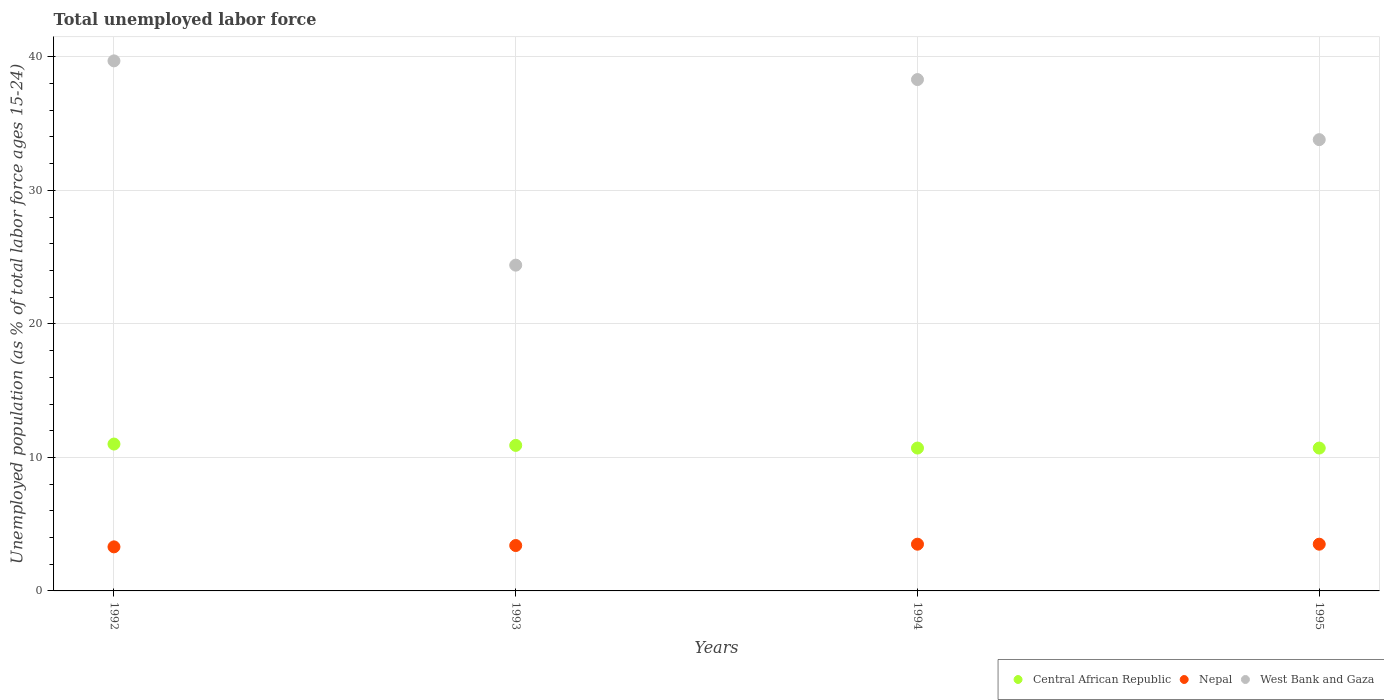Is the number of dotlines equal to the number of legend labels?
Make the answer very short. Yes. What is the percentage of unemployed population in in Central African Republic in 1993?
Make the answer very short. 10.9. Across all years, what is the maximum percentage of unemployed population in in West Bank and Gaza?
Keep it short and to the point. 39.7. Across all years, what is the minimum percentage of unemployed population in in Central African Republic?
Your answer should be compact. 10.7. In which year was the percentage of unemployed population in in West Bank and Gaza maximum?
Your answer should be compact. 1992. What is the total percentage of unemployed population in in West Bank and Gaza in the graph?
Your answer should be compact. 136.2. What is the difference between the percentage of unemployed population in in Nepal in 1992 and that in 1993?
Give a very brief answer. -0.1. What is the difference between the percentage of unemployed population in in Nepal in 1992 and the percentage of unemployed population in in Central African Republic in 1995?
Keep it short and to the point. -7.4. What is the average percentage of unemployed population in in West Bank and Gaza per year?
Provide a short and direct response. 34.05. In the year 1993, what is the difference between the percentage of unemployed population in in Nepal and percentage of unemployed population in in Central African Republic?
Give a very brief answer. -7.5. In how many years, is the percentage of unemployed population in in Nepal greater than 6 %?
Make the answer very short. 0. Is the difference between the percentage of unemployed population in in Nepal in 1992 and 1993 greater than the difference between the percentage of unemployed population in in Central African Republic in 1992 and 1993?
Ensure brevity in your answer.  No. What is the difference between the highest and the second highest percentage of unemployed population in in West Bank and Gaza?
Provide a short and direct response. 1.4. What is the difference between the highest and the lowest percentage of unemployed population in in West Bank and Gaza?
Provide a short and direct response. 15.3. Is the sum of the percentage of unemployed population in in West Bank and Gaza in 1992 and 1994 greater than the maximum percentage of unemployed population in in Central African Republic across all years?
Ensure brevity in your answer.  Yes. Does the percentage of unemployed population in in Nepal monotonically increase over the years?
Your answer should be very brief. No. How many dotlines are there?
Ensure brevity in your answer.  3. What is the difference between two consecutive major ticks on the Y-axis?
Make the answer very short. 10. Does the graph contain any zero values?
Provide a succinct answer. No. What is the title of the graph?
Give a very brief answer. Total unemployed labor force. What is the label or title of the X-axis?
Ensure brevity in your answer.  Years. What is the label or title of the Y-axis?
Provide a succinct answer. Unemployed population (as % of total labor force ages 15-24). What is the Unemployed population (as % of total labor force ages 15-24) of Central African Republic in 1992?
Your answer should be very brief. 11. What is the Unemployed population (as % of total labor force ages 15-24) of Nepal in 1992?
Offer a very short reply. 3.3. What is the Unemployed population (as % of total labor force ages 15-24) in West Bank and Gaza in 1992?
Your response must be concise. 39.7. What is the Unemployed population (as % of total labor force ages 15-24) in Central African Republic in 1993?
Provide a short and direct response. 10.9. What is the Unemployed population (as % of total labor force ages 15-24) of Nepal in 1993?
Provide a short and direct response. 3.4. What is the Unemployed population (as % of total labor force ages 15-24) of West Bank and Gaza in 1993?
Your answer should be very brief. 24.4. What is the Unemployed population (as % of total labor force ages 15-24) in Central African Republic in 1994?
Your response must be concise. 10.7. What is the Unemployed population (as % of total labor force ages 15-24) of Nepal in 1994?
Ensure brevity in your answer.  3.5. What is the Unemployed population (as % of total labor force ages 15-24) of West Bank and Gaza in 1994?
Make the answer very short. 38.3. What is the Unemployed population (as % of total labor force ages 15-24) in Central African Republic in 1995?
Give a very brief answer. 10.7. What is the Unemployed population (as % of total labor force ages 15-24) of Nepal in 1995?
Your response must be concise. 3.5. What is the Unemployed population (as % of total labor force ages 15-24) of West Bank and Gaza in 1995?
Keep it short and to the point. 33.8. Across all years, what is the maximum Unemployed population (as % of total labor force ages 15-24) of Nepal?
Provide a succinct answer. 3.5. Across all years, what is the maximum Unemployed population (as % of total labor force ages 15-24) of West Bank and Gaza?
Ensure brevity in your answer.  39.7. Across all years, what is the minimum Unemployed population (as % of total labor force ages 15-24) of Central African Republic?
Offer a terse response. 10.7. Across all years, what is the minimum Unemployed population (as % of total labor force ages 15-24) in Nepal?
Make the answer very short. 3.3. Across all years, what is the minimum Unemployed population (as % of total labor force ages 15-24) of West Bank and Gaza?
Your response must be concise. 24.4. What is the total Unemployed population (as % of total labor force ages 15-24) in Central African Republic in the graph?
Your answer should be very brief. 43.3. What is the total Unemployed population (as % of total labor force ages 15-24) of West Bank and Gaza in the graph?
Your response must be concise. 136.2. What is the difference between the Unemployed population (as % of total labor force ages 15-24) in Nepal in 1993 and that in 1994?
Give a very brief answer. -0.1. What is the difference between the Unemployed population (as % of total labor force ages 15-24) of West Bank and Gaza in 1993 and that in 1994?
Ensure brevity in your answer.  -13.9. What is the difference between the Unemployed population (as % of total labor force ages 15-24) of Central African Republic in 1994 and that in 1995?
Your answer should be compact. 0. What is the difference between the Unemployed population (as % of total labor force ages 15-24) in Central African Republic in 1992 and the Unemployed population (as % of total labor force ages 15-24) in Nepal in 1993?
Provide a succinct answer. 7.6. What is the difference between the Unemployed population (as % of total labor force ages 15-24) in Nepal in 1992 and the Unemployed population (as % of total labor force ages 15-24) in West Bank and Gaza in 1993?
Your response must be concise. -21.1. What is the difference between the Unemployed population (as % of total labor force ages 15-24) in Central African Republic in 1992 and the Unemployed population (as % of total labor force ages 15-24) in Nepal in 1994?
Your response must be concise. 7.5. What is the difference between the Unemployed population (as % of total labor force ages 15-24) in Central African Republic in 1992 and the Unemployed population (as % of total labor force ages 15-24) in West Bank and Gaza in 1994?
Provide a succinct answer. -27.3. What is the difference between the Unemployed population (as % of total labor force ages 15-24) in Nepal in 1992 and the Unemployed population (as % of total labor force ages 15-24) in West Bank and Gaza in 1994?
Provide a succinct answer. -35. What is the difference between the Unemployed population (as % of total labor force ages 15-24) of Central African Republic in 1992 and the Unemployed population (as % of total labor force ages 15-24) of Nepal in 1995?
Your response must be concise. 7.5. What is the difference between the Unemployed population (as % of total labor force ages 15-24) of Central African Republic in 1992 and the Unemployed population (as % of total labor force ages 15-24) of West Bank and Gaza in 1995?
Make the answer very short. -22.8. What is the difference between the Unemployed population (as % of total labor force ages 15-24) of Nepal in 1992 and the Unemployed population (as % of total labor force ages 15-24) of West Bank and Gaza in 1995?
Make the answer very short. -30.5. What is the difference between the Unemployed population (as % of total labor force ages 15-24) in Central African Republic in 1993 and the Unemployed population (as % of total labor force ages 15-24) in West Bank and Gaza in 1994?
Give a very brief answer. -27.4. What is the difference between the Unemployed population (as % of total labor force ages 15-24) in Nepal in 1993 and the Unemployed population (as % of total labor force ages 15-24) in West Bank and Gaza in 1994?
Provide a short and direct response. -34.9. What is the difference between the Unemployed population (as % of total labor force ages 15-24) of Central African Republic in 1993 and the Unemployed population (as % of total labor force ages 15-24) of West Bank and Gaza in 1995?
Keep it short and to the point. -22.9. What is the difference between the Unemployed population (as % of total labor force ages 15-24) in Nepal in 1993 and the Unemployed population (as % of total labor force ages 15-24) in West Bank and Gaza in 1995?
Offer a terse response. -30.4. What is the difference between the Unemployed population (as % of total labor force ages 15-24) in Central African Republic in 1994 and the Unemployed population (as % of total labor force ages 15-24) in Nepal in 1995?
Make the answer very short. 7.2. What is the difference between the Unemployed population (as % of total labor force ages 15-24) in Central African Republic in 1994 and the Unemployed population (as % of total labor force ages 15-24) in West Bank and Gaza in 1995?
Provide a short and direct response. -23.1. What is the difference between the Unemployed population (as % of total labor force ages 15-24) of Nepal in 1994 and the Unemployed population (as % of total labor force ages 15-24) of West Bank and Gaza in 1995?
Offer a very short reply. -30.3. What is the average Unemployed population (as % of total labor force ages 15-24) of Central African Republic per year?
Offer a very short reply. 10.82. What is the average Unemployed population (as % of total labor force ages 15-24) of Nepal per year?
Give a very brief answer. 3.42. What is the average Unemployed population (as % of total labor force ages 15-24) in West Bank and Gaza per year?
Ensure brevity in your answer.  34.05. In the year 1992, what is the difference between the Unemployed population (as % of total labor force ages 15-24) in Central African Republic and Unemployed population (as % of total labor force ages 15-24) in Nepal?
Give a very brief answer. 7.7. In the year 1992, what is the difference between the Unemployed population (as % of total labor force ages 15-24) in Central African Republic and Unemployed population (as % of total labor force ages 15-24) in West Bank and Gaza?
Ensure brevity in your answer.  -28.7. In the year 1992, what is the difference between the Unemployed population (as % of total labor force ages 15-24) in Nepal and Unemployed population (as % of total labor force ages 15-24) in West Bank and Gaza?
Your response must be concise. -36.4. In the year 1993, what is the difference between the Unemployed population (as % of total labor force ages 15-24) of Central African Republic and Unemployed population (as % of total labor force ages 15-24) of West Bank and Gaza?
Your answer should be compact. -13.5. In the year 1994, what is the difference between the Unemployed population (as % of total labor force ages 15-24) of Central African Republic and Unemployed population (as % of total labor force ages 15-24) of Nepal?
Offer a terse response. 7.2. In the year 1994, what is the difference between the Unemployed population (as % of total labor force ages 15-24) of Central African Republic and Unemployed population (as % of total labor force ages 15-24) of West Bank and Gaza?
Your response must be concise. -27.6. In the year 1994, what is the difference between the Unemployed population (as % of total labor force ages 15-24) in Nepal and Unemployed population (as % of total labor force ages 15-24) in West Bank and Gaza?
Ensure brevity in your answer.  -34.8. In the year 1995, what is the difference between the Unemployed population (as % of total labor force ages 15-24) of Central African Republic and Unemployed population (as % of total labor force ages 15-24) of West Bank and Gaza?
Your answer should be very brief. -23.1. In the year 1995, what is the difference between the Unemployed population (as % of total labor force ages 15-24) of Nepal and Unemployed population (as % of total labor force ages 15-24) of West Bank and Gaza?
Keep it short and to the point. -30.3. What is the ratio of the Unemployed population (as % of total labor force ages 15-24) in Central African Republic in 1992 to that in 1993?
Your answer should be very brief. 1.01. What is the ratio of the Unemployed population (as % of total labor force ages 15-24) of Nepal in 1992 to that in 1993?
Keep it short and to the point. 0.97. What is the ratio of the Unemployed population (as % of total labor force ages 15-24) of West Bank and Gaza in 1992 to that in 1993?
Provide a succinct answer. 1.63. What is the ratio of the Unemployed population (as % of total labor force ages 15-24) in Central African Republic in 1992 to that in 1994?
Give a very brief answer. 1.03. What is the ratio of the Unemployed population (as % of total labor force ages 15-24) of Nepal in 1992 to that in 1994?
Give a very brief answer. 0.94. What is the ratio of the Unemployed population (as % of total labor force ages 15-24) in West Bank and Gaza in 1992 to that in 1994?
Provide a succinct answer. 1.04. What is the ratio of the Unemployed population (as % of total labor force ages 15-24) in Central African Republic in 1992 to that in 1995?
Your answer should be compact. 1.03. What is the ratio of the Unemployed population (as % of total labor force ages 15-24) of Nepal in 1992 to that in 1995?
Provide a succinct answer. 0.94. What is the ratio of the Unemployed population (as % of total labor force ages 15-24) in West Bank and Gaza in 1992 to that in 1995?
Provide a short and direct response. 1.17. What is the ratio of the Unemployed population (as % of total labor force ages 15-24) of Central African Republic in 1993 to that in 1994?
Your response must be concise. 1.02. What is the ratio of the Unemployed population (as % of total labor force ages 15-24) in Nepal in 1993 to that in 1994?
Your answer should be compact. 0.97. What is the ratio of the Unemployed population (as % of total labor force ages 15-24) of West Bank and Gaza in 1993 to that in 1994?
Offer a very short reply. 0.64. What is the ratio of the Unemployed population (as % of total labor force ages 15-24) of Central African Republic in 1993 to that in 1995?
Ensure brevity in your answer.  1.02. What is the ratio of the Unemployed population (as % of total labor force ages 15-24) of Nepal in 1993 to that in 1995?
Your answer should be compact. 0.97. What is the ratio of the Unemployed population (as % of total labor force ages 15-24) of West Bank and Gaza in 1993 to that in 1995?
Offer a terse response. 0.72. What is the ratio of the Unemployed population (as % of total labor force ages 15-24) of Central African Republic in 1994 to that in 1995?
Offer a terse response. 1. What is the ratio of the Unemployed population (as % of total labor force ages 15-24) of Nepal in 1994 to that in 1995?
Give a very brief answer. 1. What is the ratio of the Unemployed population (as % of total labor force ages 15-24) in West Bank and Gaza in 1994 to that in 1995?
Your response must be concise. 1.13. What is the difference between the highest and the lowest Unemployed population (as % of total labor force ages 15-24) in Central African Republic?
Give a very brief answer. 0.3. What is the difference between the highest and the lowest Unemployed population (as % of total labor force ages 15-24) in West Bank and Gaza?
Give a very brief answer. 15.3. 